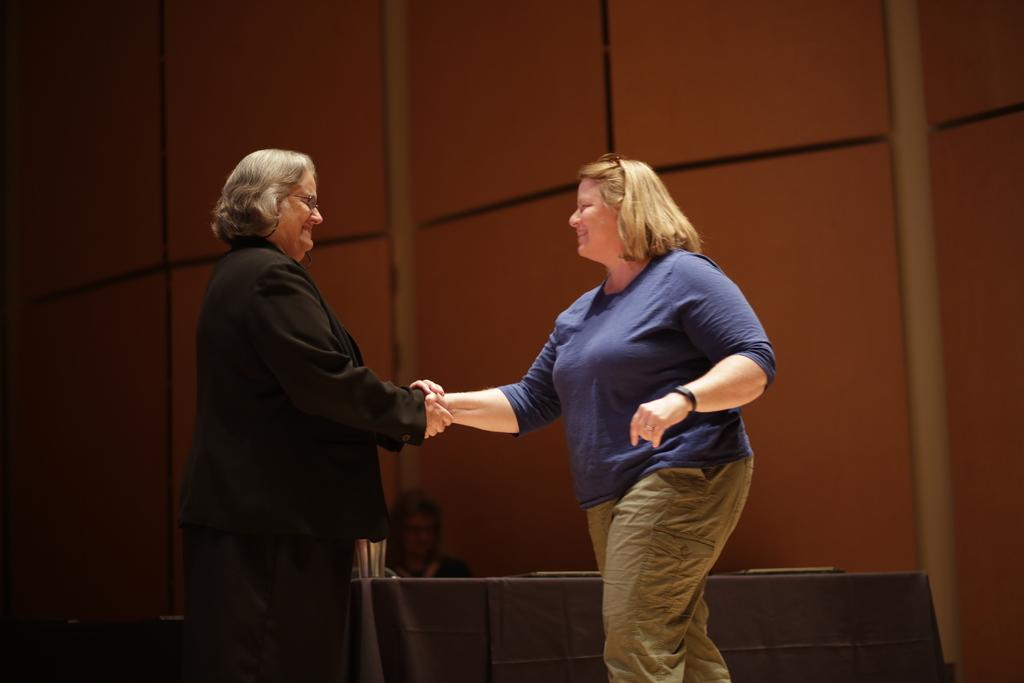How many people are in the image? There are two persons in the image. What are the persons wearing? The persons are wearing clothes. What are the persons doing in the image? The persons are shaking hands. What is in front of the persons? There is a table in front of the persons. What can be seen in the background of the image? There is a wall in the background of the image. What type of crack can be heard in the image? There is no crack or sound present in the image; it is a still image of two persons shaking hands. What type of celery is being used as a prop in the image? There is no celery present in the image; it features two persons shaking hands with a table and a wall in the background. 